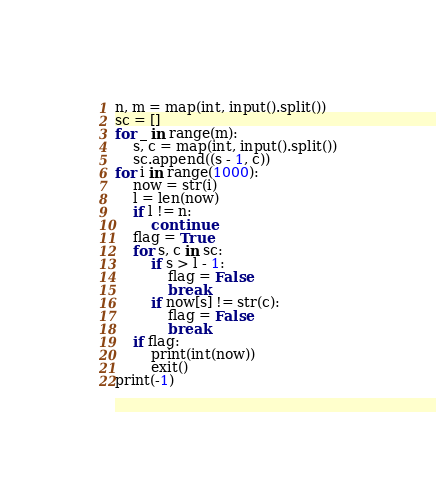Convert code to text. <code><loc_0><loc_0><loc_500><loc_500><_Python_>n, m = map(int, input().split())
sc = []
for _ in range(m):
    s, c = map(int, input().split())
    sc.append((s - 1, c))
for i in range(1000):
    now = str(i)
    l = len(now)
    if l != n:
        continue
    flag = True
    for s, c in sc:
        if s > l - 1:
            flag = False
            break
        if now[s] != str(c):
            flag = False
            break
    if flag:
        print(int(now))
        exit()
print(-1)</code> 